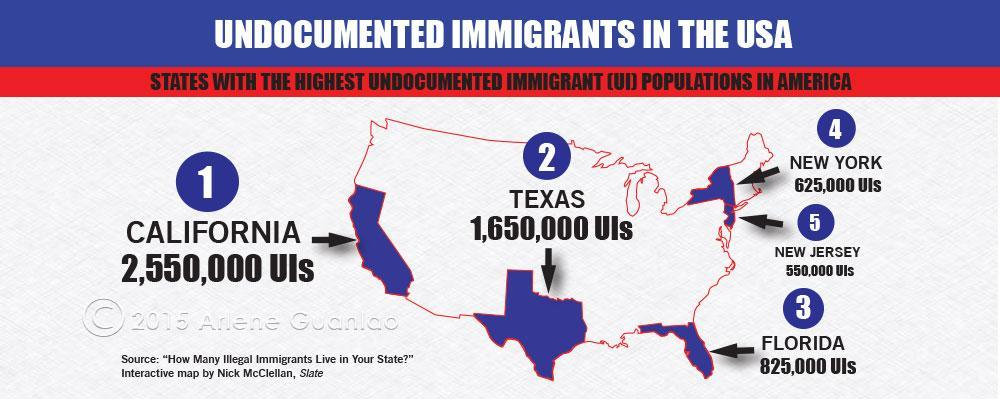Which state has the third highest population of undocumented immigrants?
Answer the question with a short phrase. FLORIDA What is the undocumented immigrant population in Texas? 1,650,000 